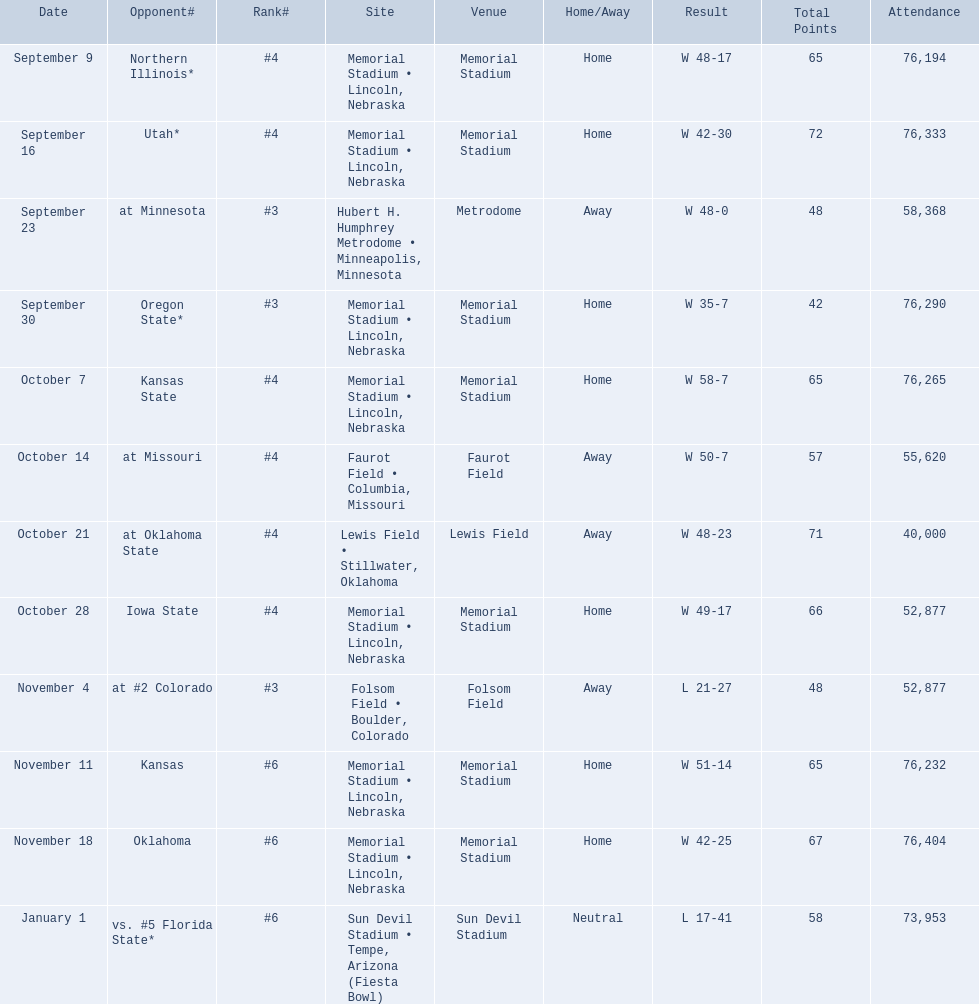Which opponenets did the nebraska cornhuskers score fewer than 40 points against? Oregon State*, at #2 Colorado, vs. #5 Florida State*. Of these games, which ones had an attendance of greater than 70,000? Oregon State*, vs. #5 Florida State*. Which of these opponents did they beat? Oregon State*. How many people were in attendance at that game? 76,290. 